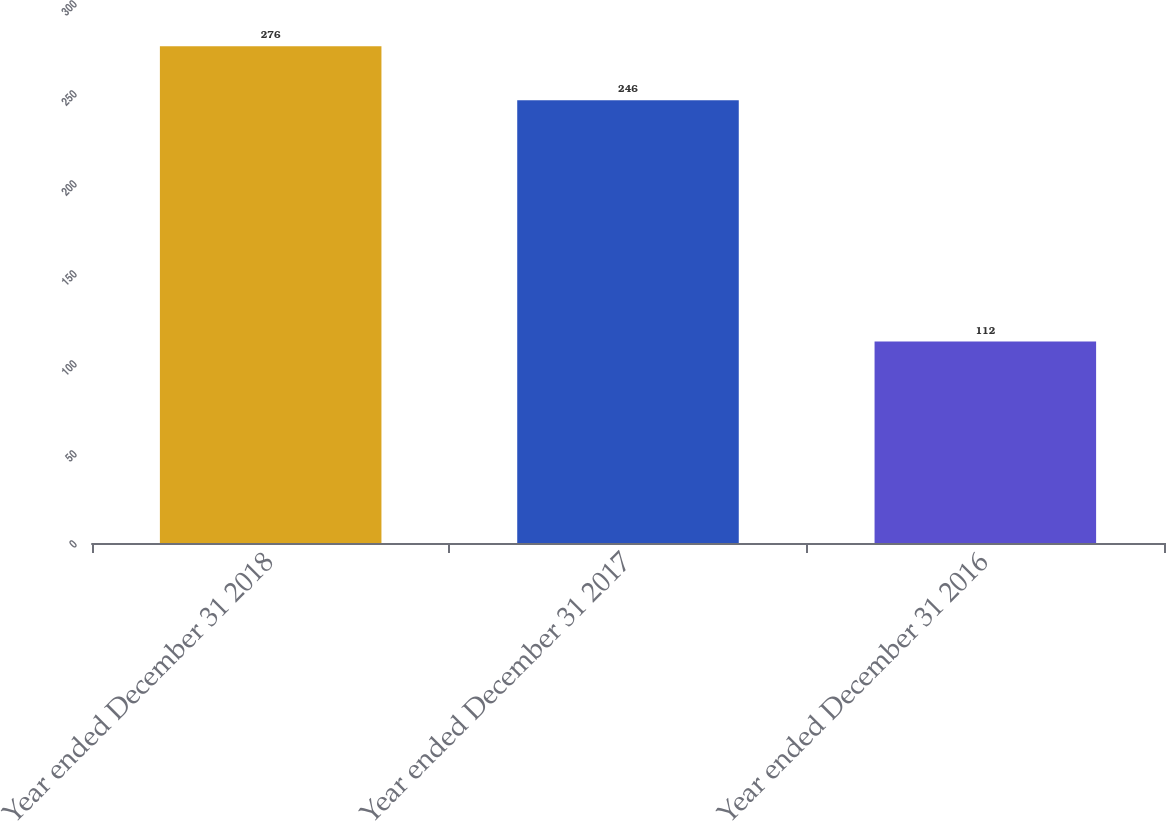Convert chart to OTSL. <chart><loc_0><loc_0><loc_500><loc_500><bar_chart><fcel>Year ended December 31 2018<fcel>Year ended December 31 2017<fcel>Year ended December 31 2016<nl><fcel>276<fcel>246<fcel>112<nl></chart> 